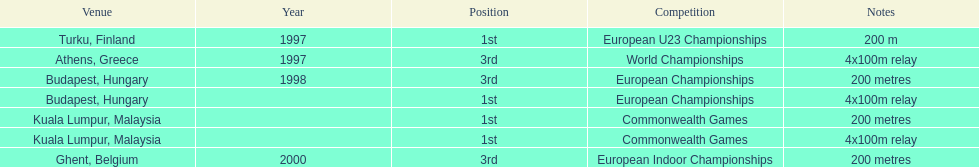How many events were won in malaysia? 2. Write the full table. {'header': ['Venue', 'Year', 'Position', 'Competition', 'Notes'], 'rows': [['Turku, Finland', '1997', '1st', 'European U23 Championships', '200 m'], ['Athens, Greece', '1997', '3rd', 'World Championships', '4x100m relay'], ['Budapest, Hungary', '1998', '3rd', 'European Championships', '200 metres'], ['Budapest, Hungary', '', '1st', 'European Championships', '4x100m relay'], ['Kuala Lumpur, Malaysia', '', '1st', 'Commonwealth Games', '200 metres'], ['Kuala Lumpur, Malaysia', '', '1st', 'Commonwealth Games', '4x100m relay'], ['Ghent, Belgium', '2000', '3rd', 'European Indoor Championships', '200 metres']]} 